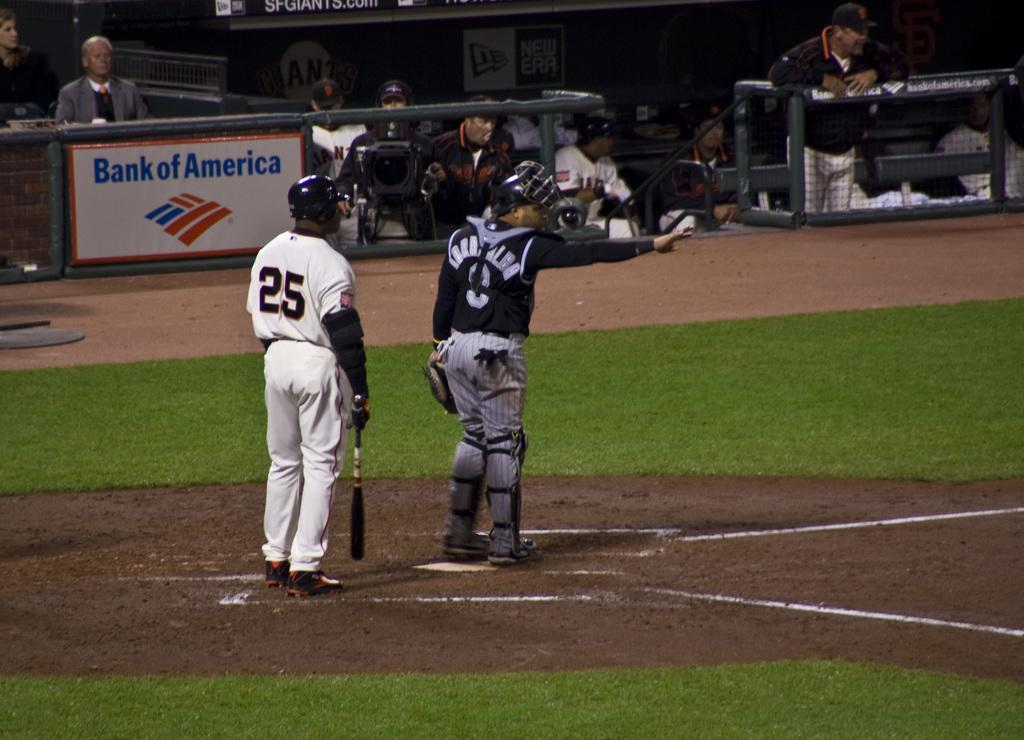<image>
Write a terse but informative summary of the picture. Bank of America is a donor to the baseball field 